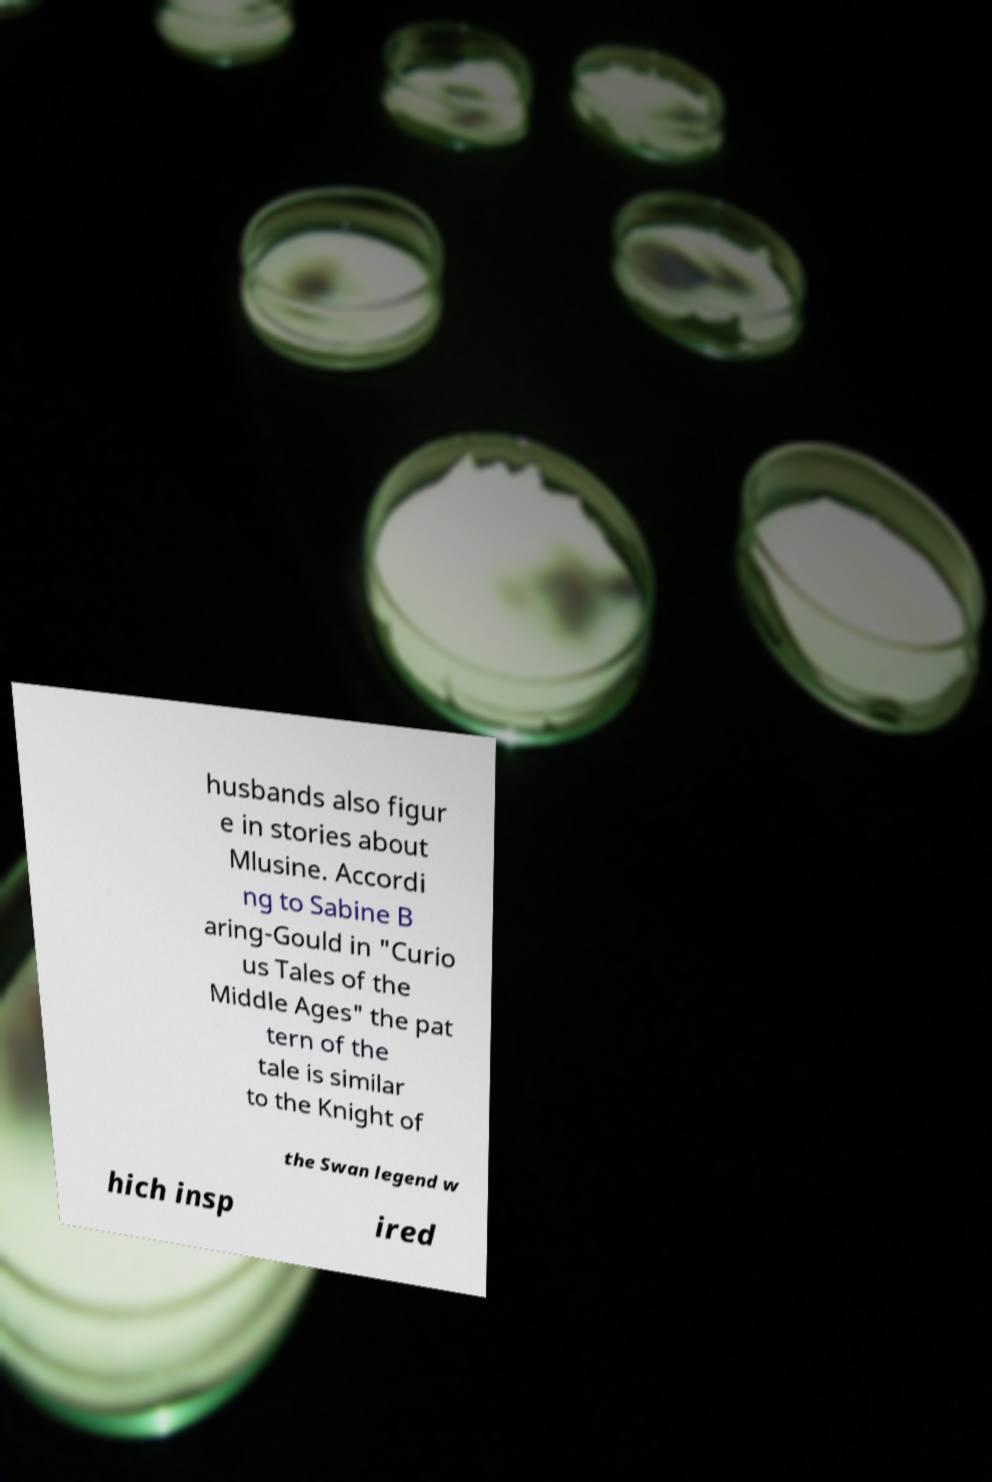Could you assist in decoding the text presented in this image and type it out clearly? husbands also figur e in stories about Mlusine. Accordi ng to Sabine B aring-Gould in "Curio us Tales of the Middle Ages" the pat tern of the tale is similar to the Knight of the Swan legend w hich insp ired 